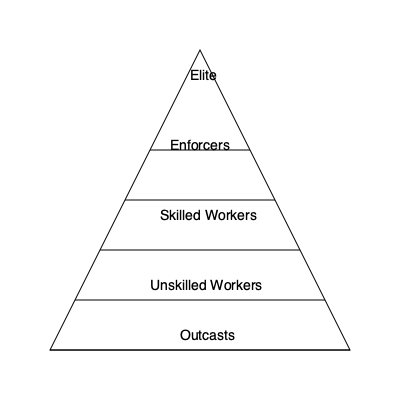Analyze the social hierarchy depicted in the pyramid diagram. How might the distribution of power and resources in this dystopian society contribute to its stability or instability? Consider the potential for social mobility and the implications for those at different levels of the hierarchy. To analyze the social hierarchy in this dystopian society, we need to consider several factors:

1. Structure of the hierarchy:
   - The pyramid shows five distinct levels: Elite, Enforcers, Skilled Workers, Unskilled Workers, and Outcasts.
   - The shape indicates a small number of elites at the top and a large base of lower classes.

2. Distribution of power:
   - Elite: Likely hold the most power and control resources.
   - Enforcers: Maintain order and enforce rules set by the elite.
   - Skilled Workers: Possess valuable skills but limited power.
   - Unskilled Workers: Little power or influence.
   - Outcasts: Virtually powerless and marginalized.

3. Stability factors:
   - The presence of Enforcers suggests a system of control to maintain order.
   - A large base of workers (skilled and unskilled) supports the economy.
   - The pyramid structure implies a clear power dynamic, which can be stable if accepted.

4. Instability factors:
   - Large disparity between top and bottom may breed resentment.
   - Limited social mobility could lead to frustration and unrest.
   - Outcasts may have nothing to lose, potentially becoming a source of rebellion.

5. Social mobility:
   - The rigid structure suggests limited upward mobility.
   - Movement between adjacent levels might be possible but likely difficult.
   - Downward mobility (e.g., from Skilled to Unskilled) may be more common.

6. Implications for different levels:
   - Elite: Benefit most but may fear losing power.
   - Enforcers: Privileged position but caught between elite and lower classes.
   - Skilled Workers: May have some opportunities but limited influence.
   - Unskilled Workers: Likely struggle with limited resources and opportunities.
   - Outcasts: Face severe hardship and exclusion.

The stability of this system depends on the balance between the elite's ability to maintain control (through Enforcers and resource distribution) and the lower classes' acceptance or resistance to their position. The lack of social mobility and the presence of a marginalized group (Outcasts) create potential for instability and rebellion.
Answer: The hierarchical structure contributes to stability through clear power dynamics and control mechanisms, but risks instability due to stark inequality, limited social mobility, and potential resentment from lower classes. 